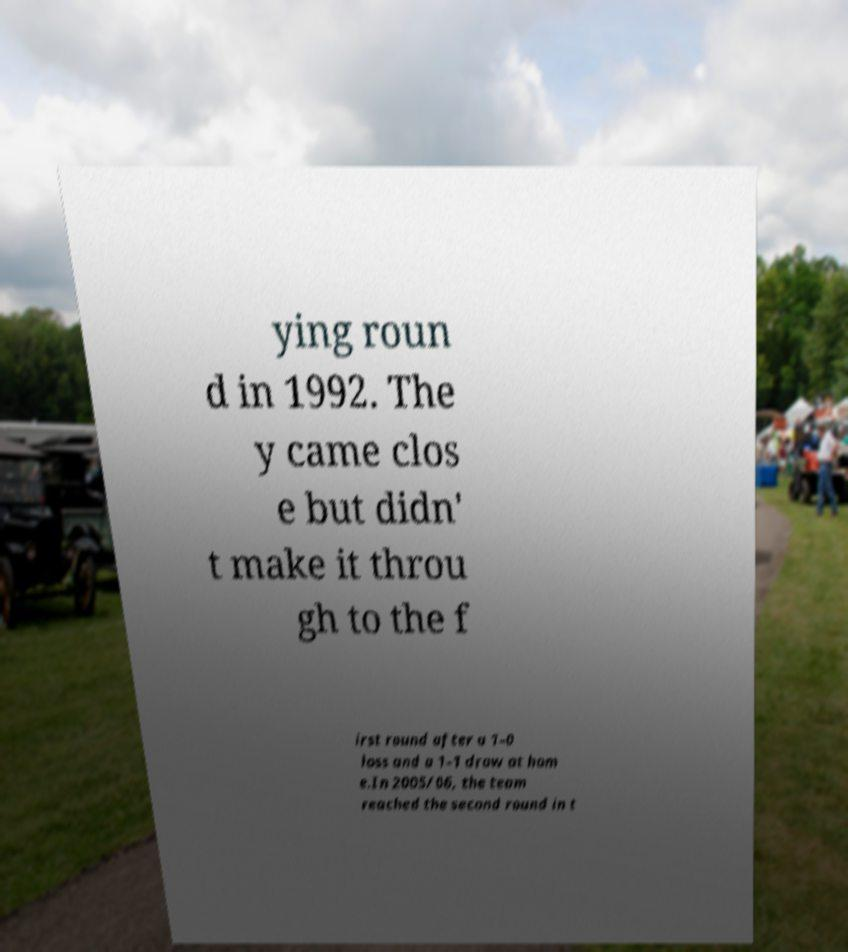For documentation purposes, I need the text within this image transcribed. Could you provide that? ying roun d in 1992. The y came clos e but didn' t make it throu gh to the f irst round after a 1–0 loss and a 1–1 draw at hom e.In 2005/06, the team reached the second round in t 